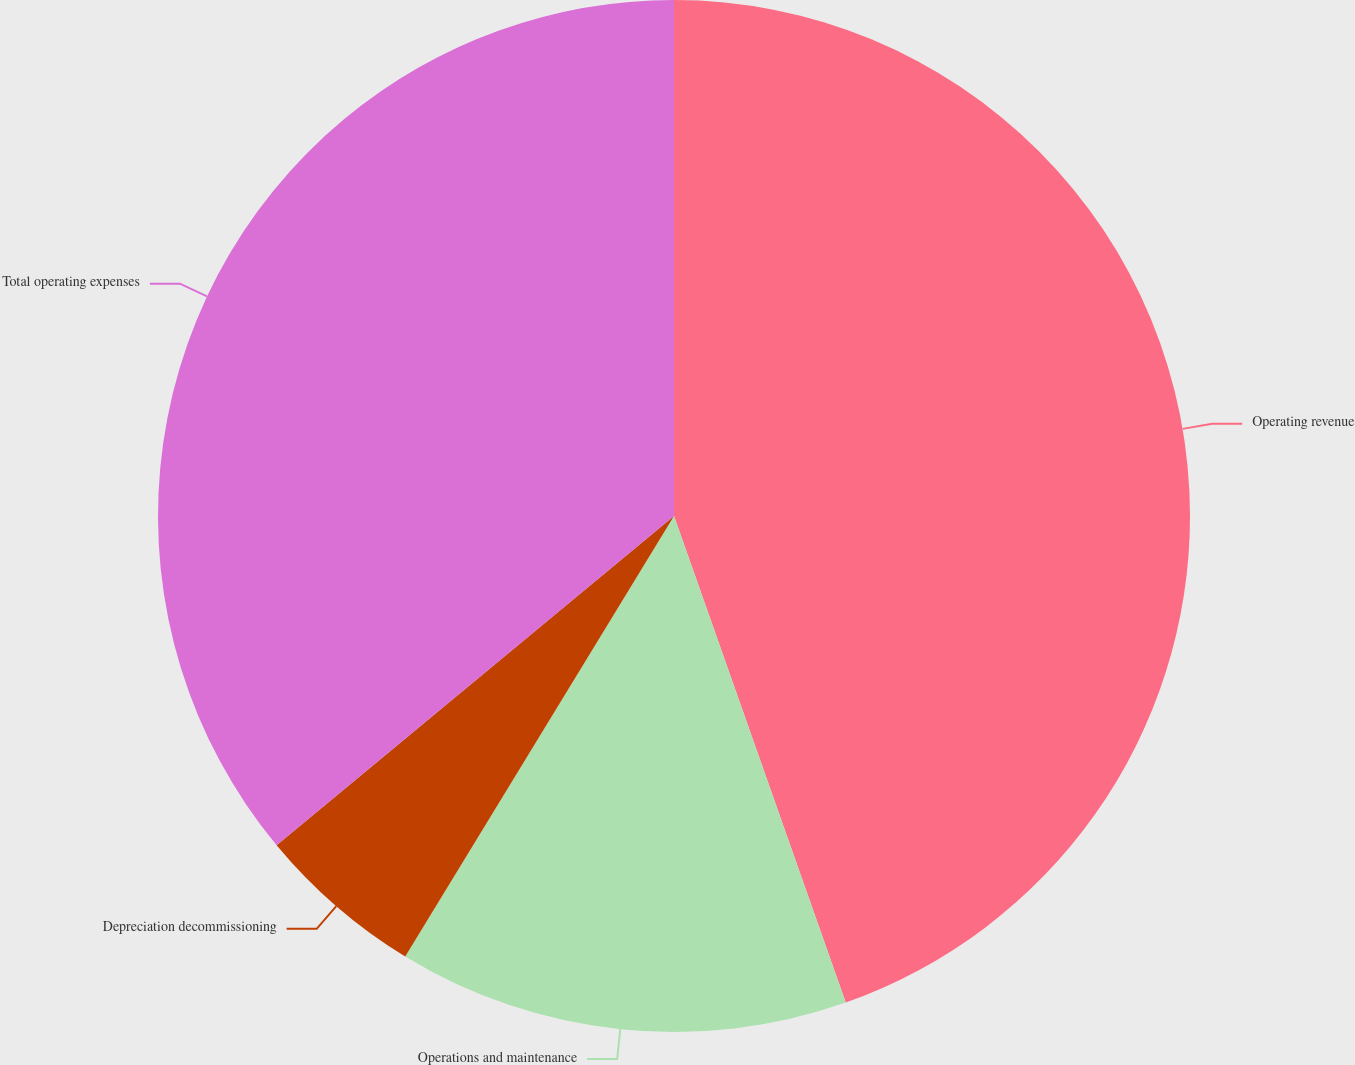<chart> <loc_0><loc_0><loc_500><loc_500><pie_chart><fcel>Operating revenue<fcel>Operations and maintenance<fcel>Depreciation decommissioning<fcel>Total operating expenses<nl><fcel>44.6%<fcel>14.12%<fcel>5.27%<fcel>36.01%<nl></chart> 